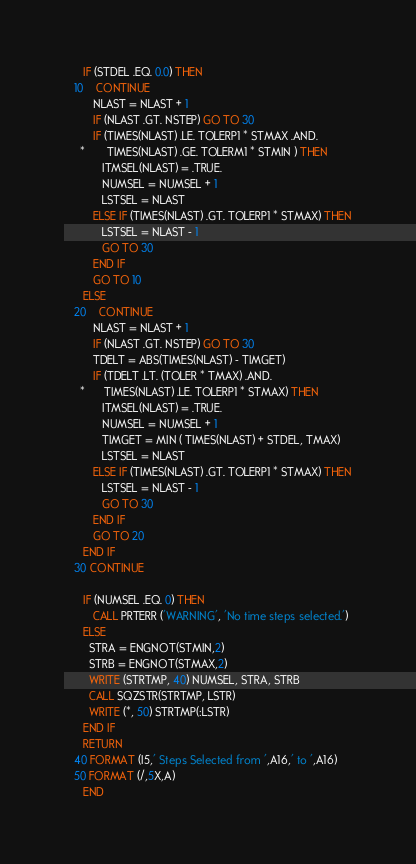Convert code to text. <code><loc_0><loc_0><loc_500><loc_500><_FORTRAN_>
      IF (STDEL .EQ. 0.0) THEN
   10    CONTINUE
         NLAST = NLAST + 1
         IF (NLAST .GT. NSTEP) GO TO 30
         IF (TIMES(NLAST) .LE. TOLERP1 * STMAX .AND.
     *       TIMES(NLAST) .GE. TOLERM1 * STMIN ) THEN
            ITMSEL(NLAST) = .TRUE.
            NUMSEL = NUMSEL + 1
            LSTSEL = NLAST
         ELSE IF (TIMES(NLAST) .GT. TOLERP1 * STMAX) THEN
            LSTSEL = NLAST - 1
            GO TO 30
         END IF
         GO TO 10
      ELSE
   20    CONTINUE
         NLAST = NLAST + 1
         IF (NLAST .GT. NSTEP) GO TO 30
         TDELT = ABS(TIMES(NLAST) - TIMGET)
         IF (TDELT .LT. (TOLER * TMAX) .AND.
     *      TIMES(NLAST) .LE. TOLERP1 * STMAX) THEN
            ITMSEL(NLAST) = .TRUE.
            NUMSEL = NUMSEL + 1
            TIMGET = MIN ( TIMES(NLAST) + STDEL, TMAX)
            LSTSEL = NLAST
         ELSE IF (TIMES(NLAST) .GT. TOLERP1 * STMAX) THEN
            LSTSEL = NLAST - 1
            GO TO 30
         END IF
         GO TO 20
      END IF
   30 CONTINUE

      IF (NUMSEL .EQ. 0) THEN
         CALL PRTERR ('WARNING', 'No time steps selected.')
      ELSE
        STRA = ENGNOT(STMIN,2)
        STRB = ENGNOT(STMAX,2)
        WRITE (STRTMP, 40) NUMSEL, STRA, STRB
        CALL SQZSTR(STRTMP, LSTR)
        WRITE (*, 50) STRTMP(:LSTR)
      END IF
      RETURN
   40 FORMAT (I5,' Steps Selected from ',A16,' to ',A16)
   50 FORMAT (/,5X,A)
      END
</code> 